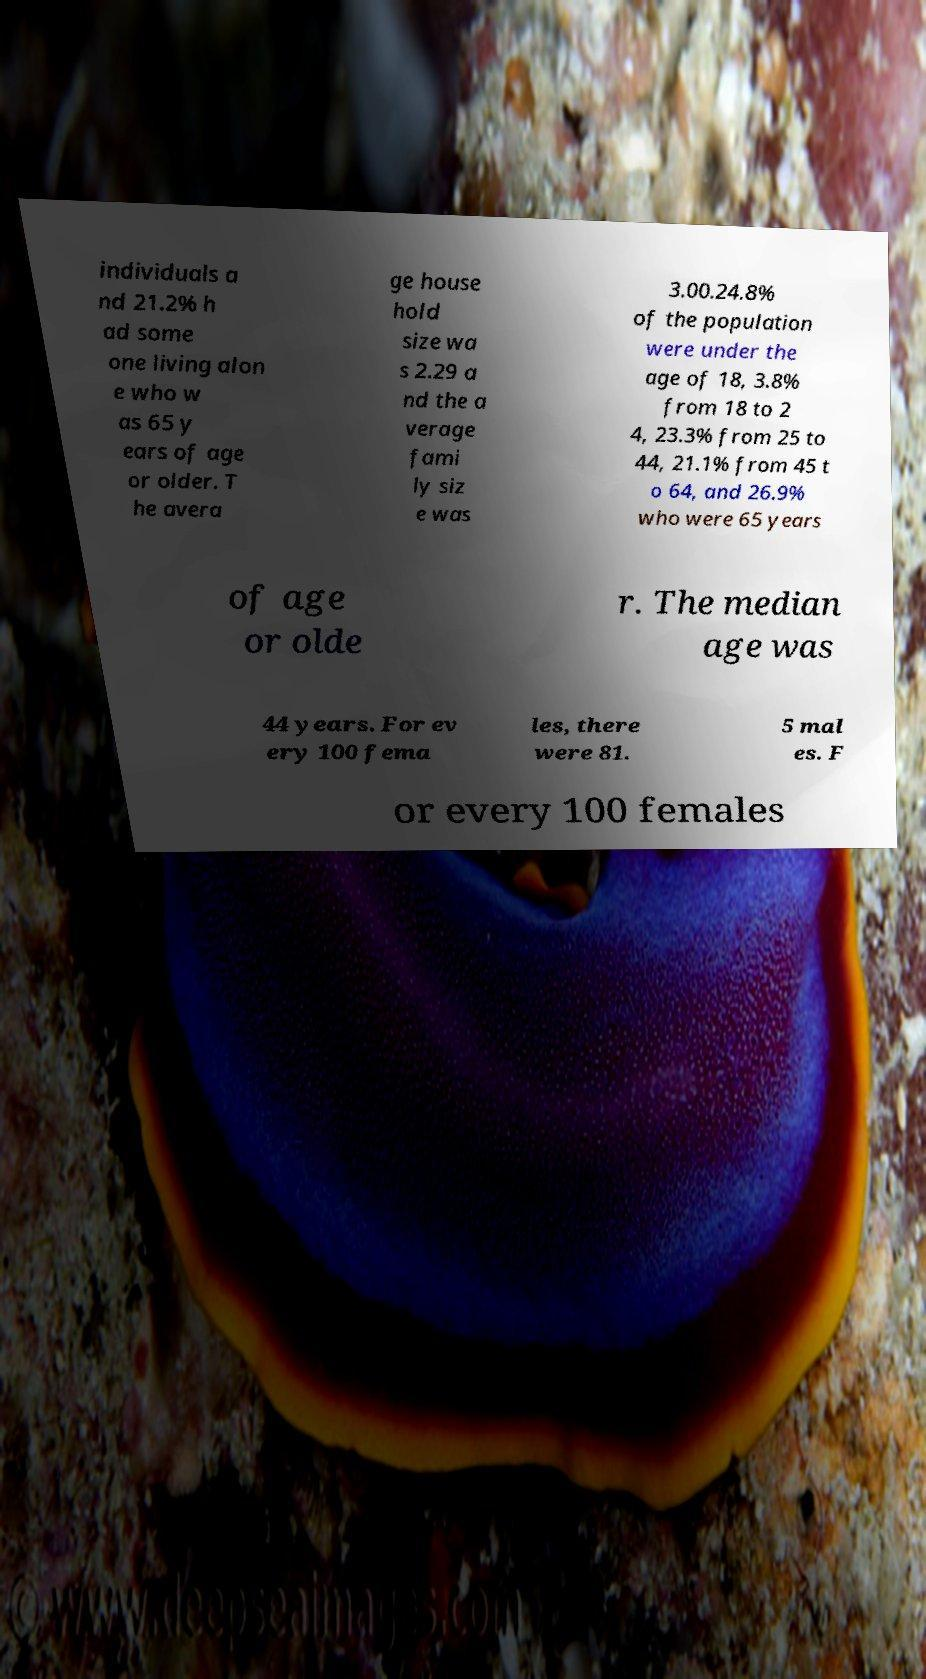Please read and relay the text visible in this image. What does it say? individuals a nd 21.2% h ad some one living alon e who w as 65 y ears of age or older. T he avera ge house hold size wa s 2.29 a nd the a verage fami ly siz e was 3.00.24.8% of the population were under the age of 18, 3.8% from 18 to 2 4, 23.3% from 25 to 44, 21.1% from 45 t o 64, and 26.9% who were 65 years of age or olde r. The median age was 44 years. For ev ery 100 fema les, there were 81. 5 mal es. F or every 100 females 